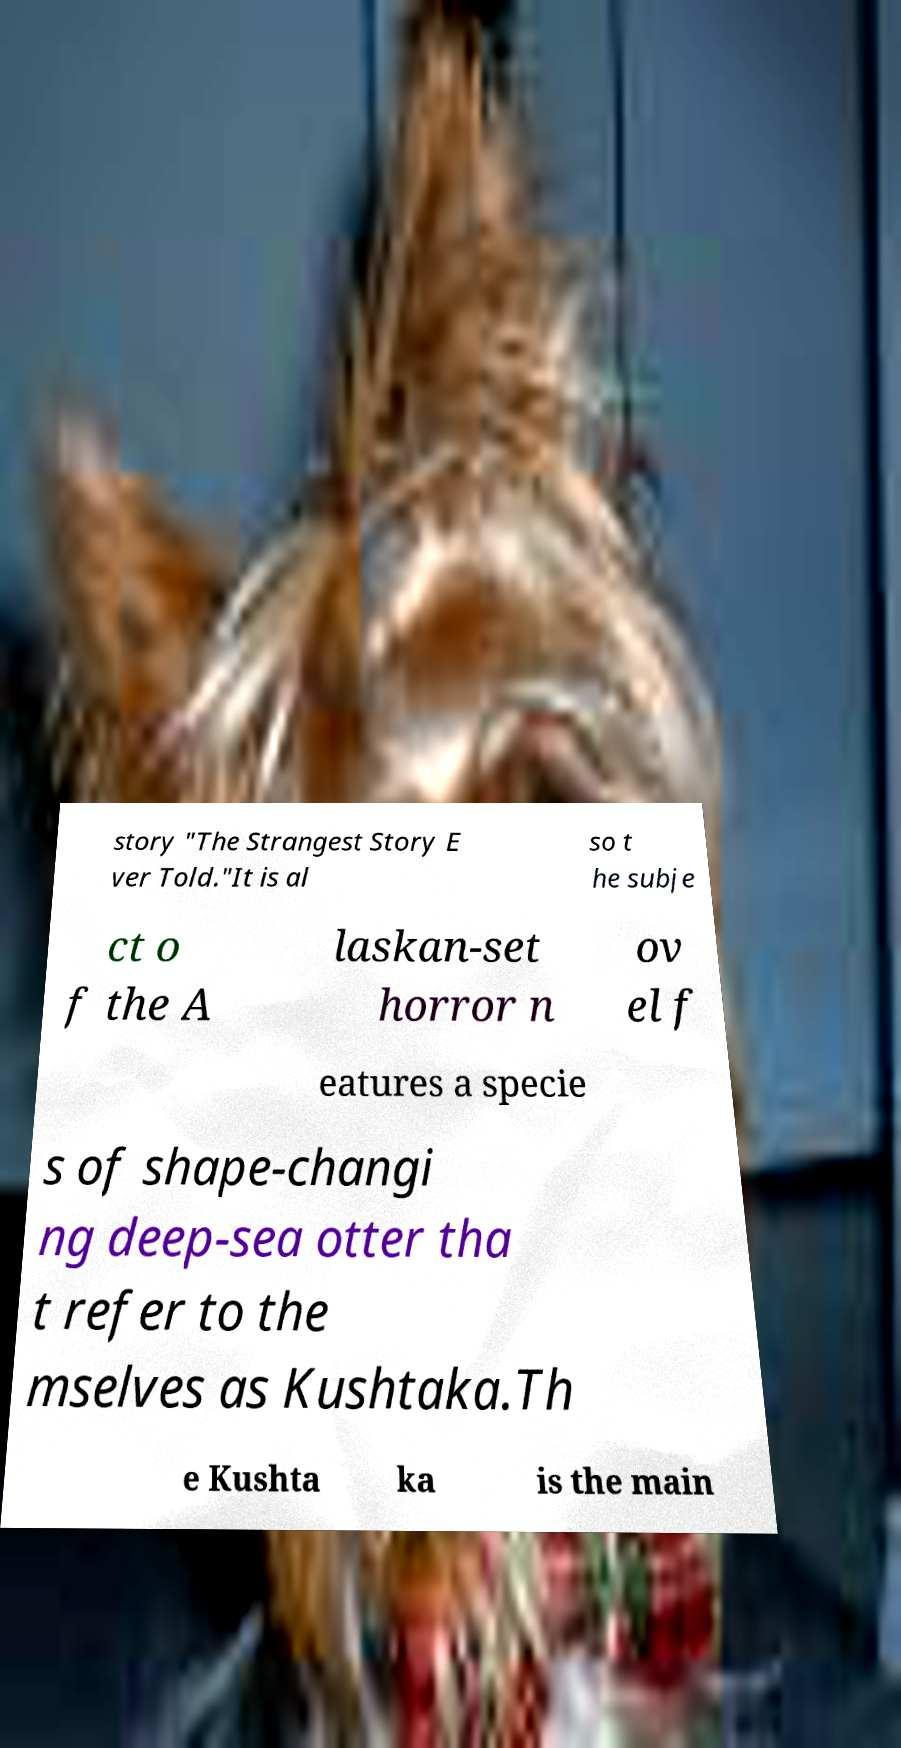For documentation purposes, I need the text within this image transcribed. Could you provide that? story "The Strangest Story E ver Told."It is al so t he subje ct o f the A laskan-set horror n ov el f eatures a specie s of shape-changi ng deep-sea otter tha t refer to the mselves as Kushtaka.Th e Kushta ka is the main 